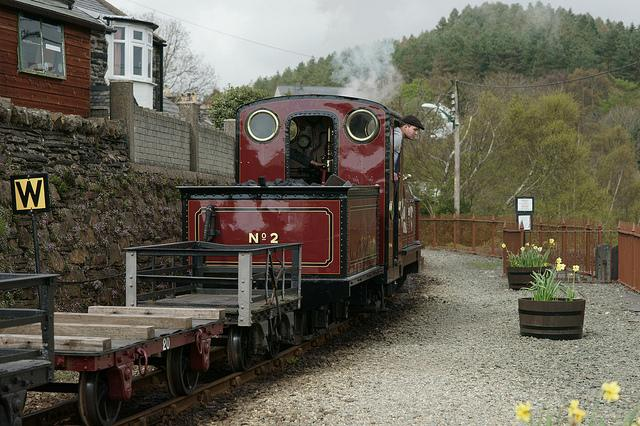Why are those flowers growing in those bins?

Choices:
A) bees
B) birds
C) weeds
D) gardener gardener 